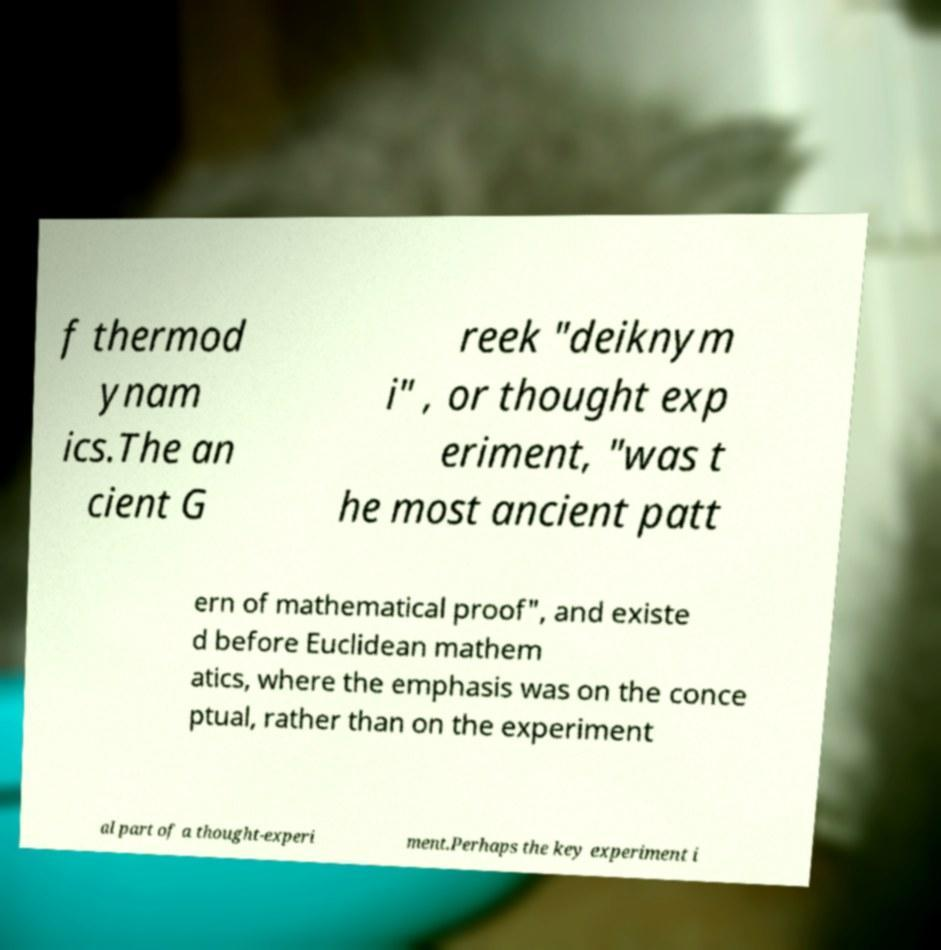Could you assist in decoding the text presented in this image and type it out clearly? f thermod ynam ics.The an cient G reek "deiknym i" , or thought exp eriment, "was t he most ancient patt ern of mathematical proof", and existe d before Euclidean mathem atics, where the emphasis was on the conce ptual, rather than on the experiment al part of a thought-experi ment.Perhaps the key experiment i 